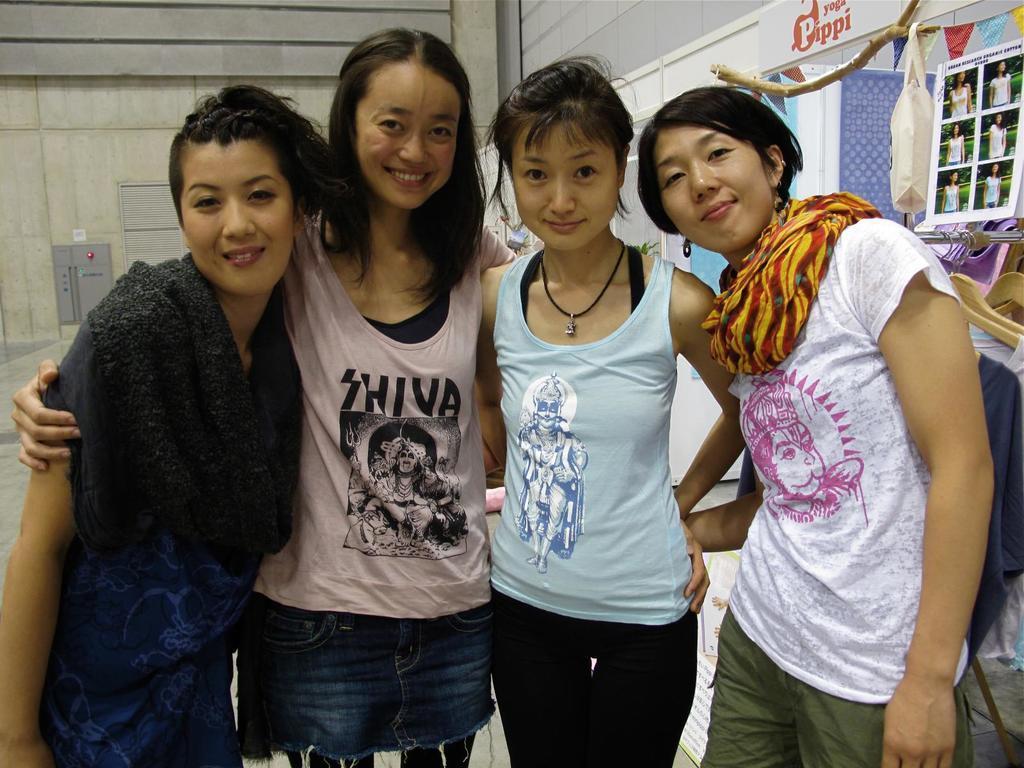Could you give a brief overview of what you see in this image? In the foreground of the picture we can see a group of women standing. On the right we can see photographs, ribbons, cover and various objects. On the left it is looking like a glass window. In the background there is a wall. 